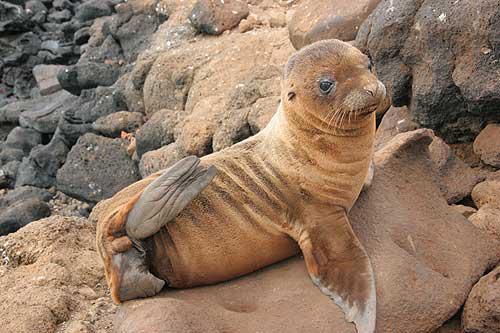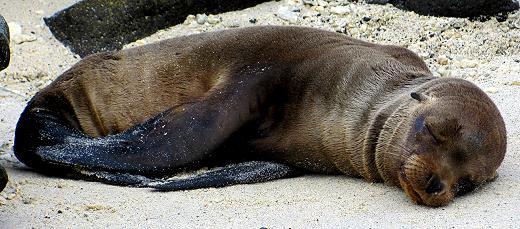The first image is the image on the left, the second image is the image on the right. For the images displayed, is the sentence "There are exactly two sea lions in total." factually correct? Answer yes or no. Yes. The first image is the image on the left, the second image is the image on the right. Examine the images to the left and right. Is the description "One image features a baby sea lion next to an adult sea lion" accurate? Answer yes or no. No. 